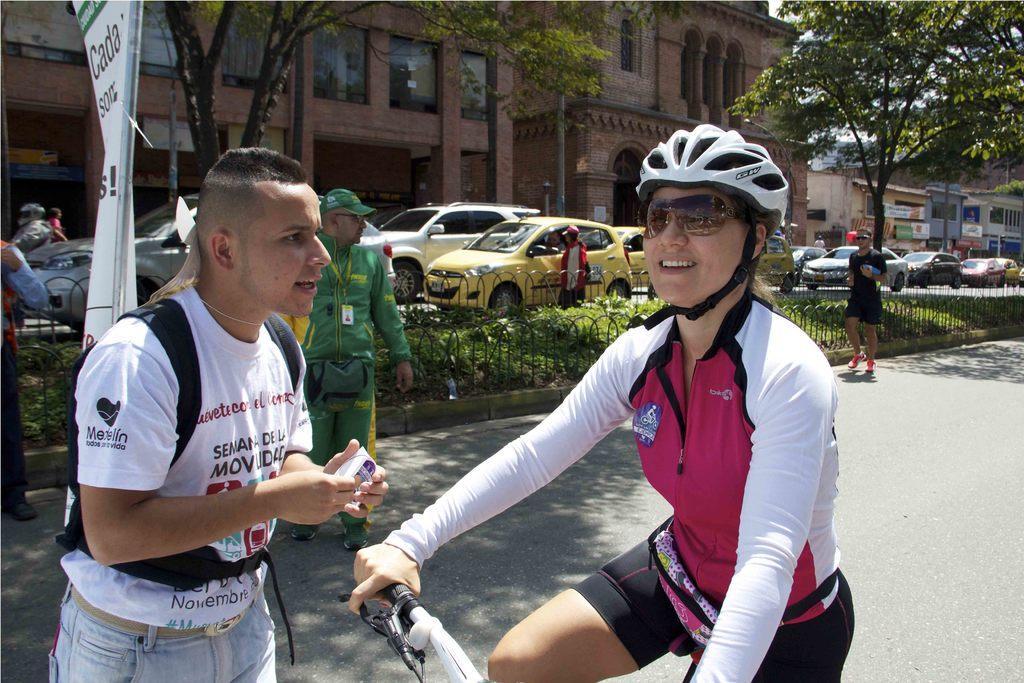Could you give a brief overview of what you see in this image? Here we can see a woman riding the bicycle on the road, and in front a person is standing and holding something in the hands, and at back here are the trees, and here are the cars travelling on the road, and here is the building. 